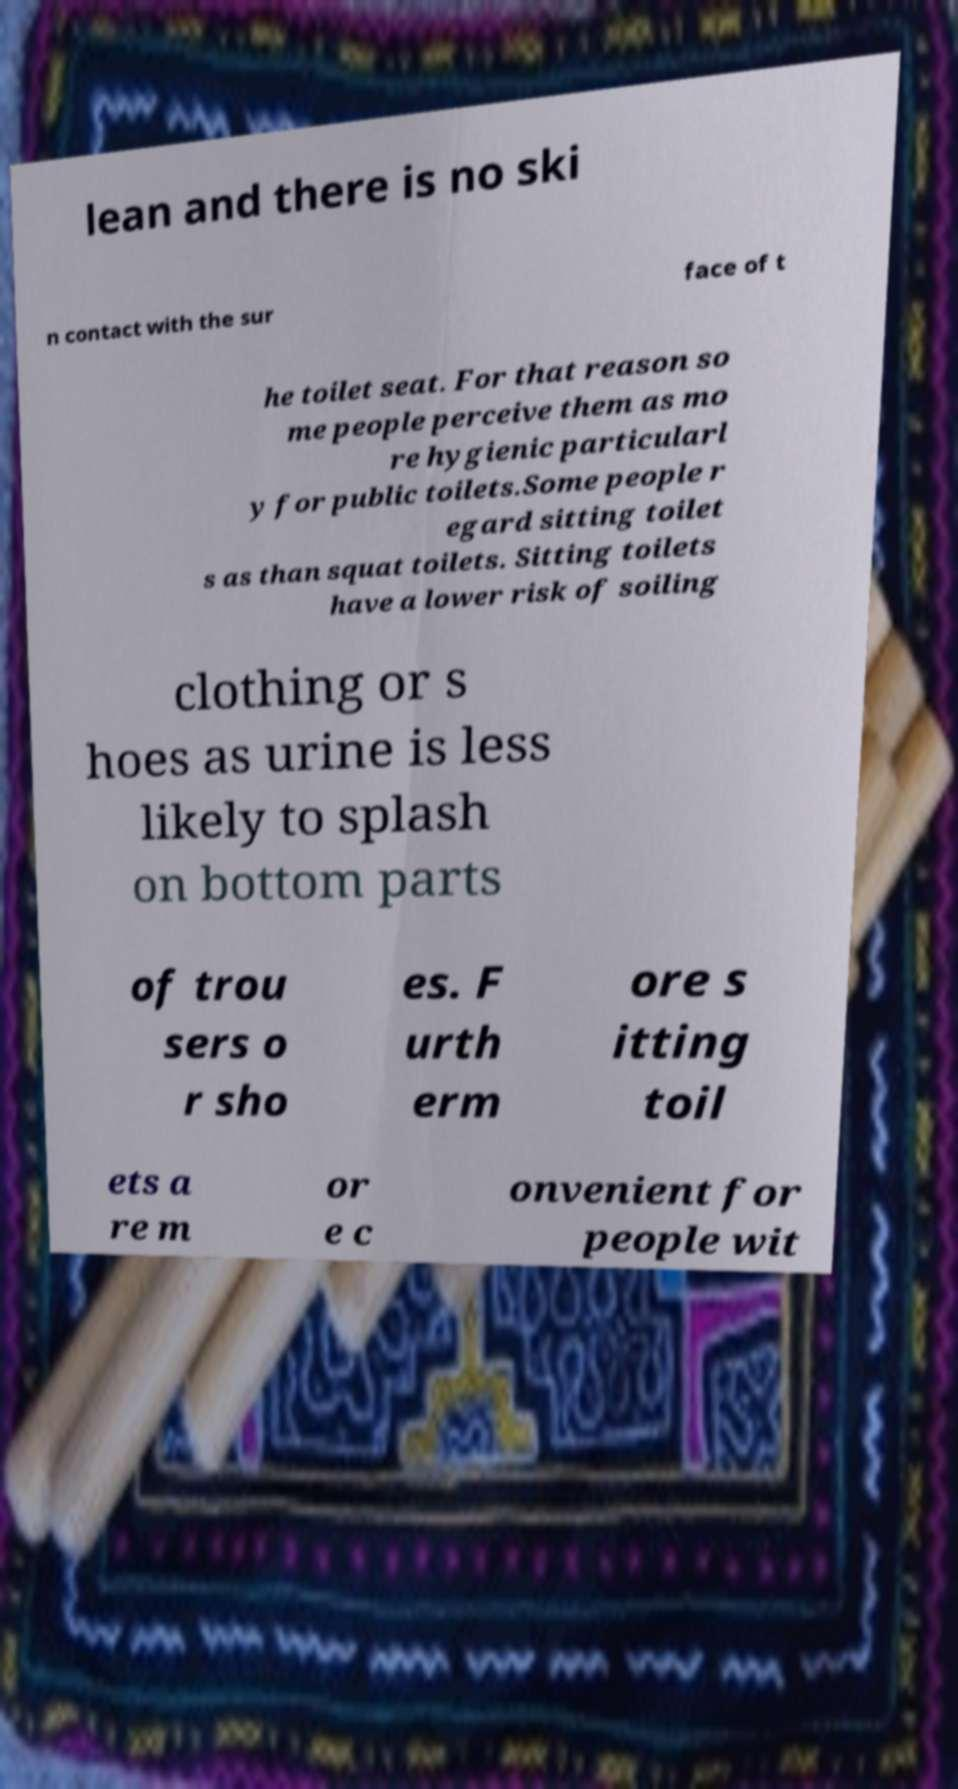There's text embedded in this image that I need extracted. Can you transcribe it verbatim? lean and there is no ski n contact with the sur face of t he toilet seat. For that reason so me people perceive them as mo re hygienic particularl y for public toilets.Some people r egard sitting toilet s as than squat toilets. Sitting toilets have a lower risk of soiling clothing or s hoes as urine is less likely to splash on bottom parts of trou sers o r sho es. F urth erm ore s itting toil ets a re m or e c onvenient for people wit 